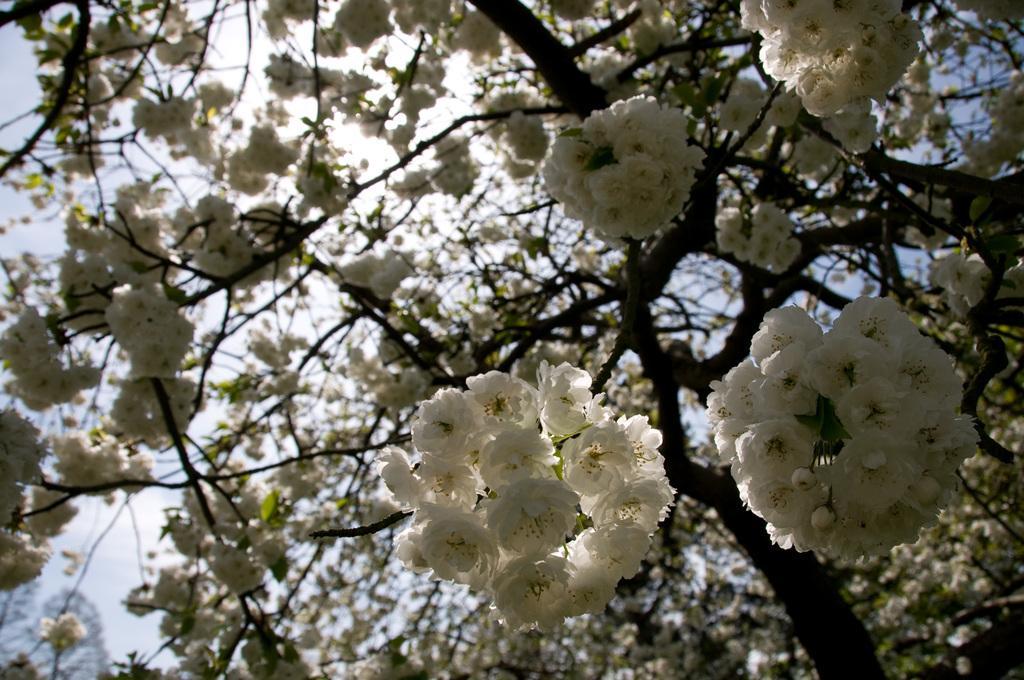How would you summarize this image in a sentence or two? In the center of the image there is a tree with flowers. 